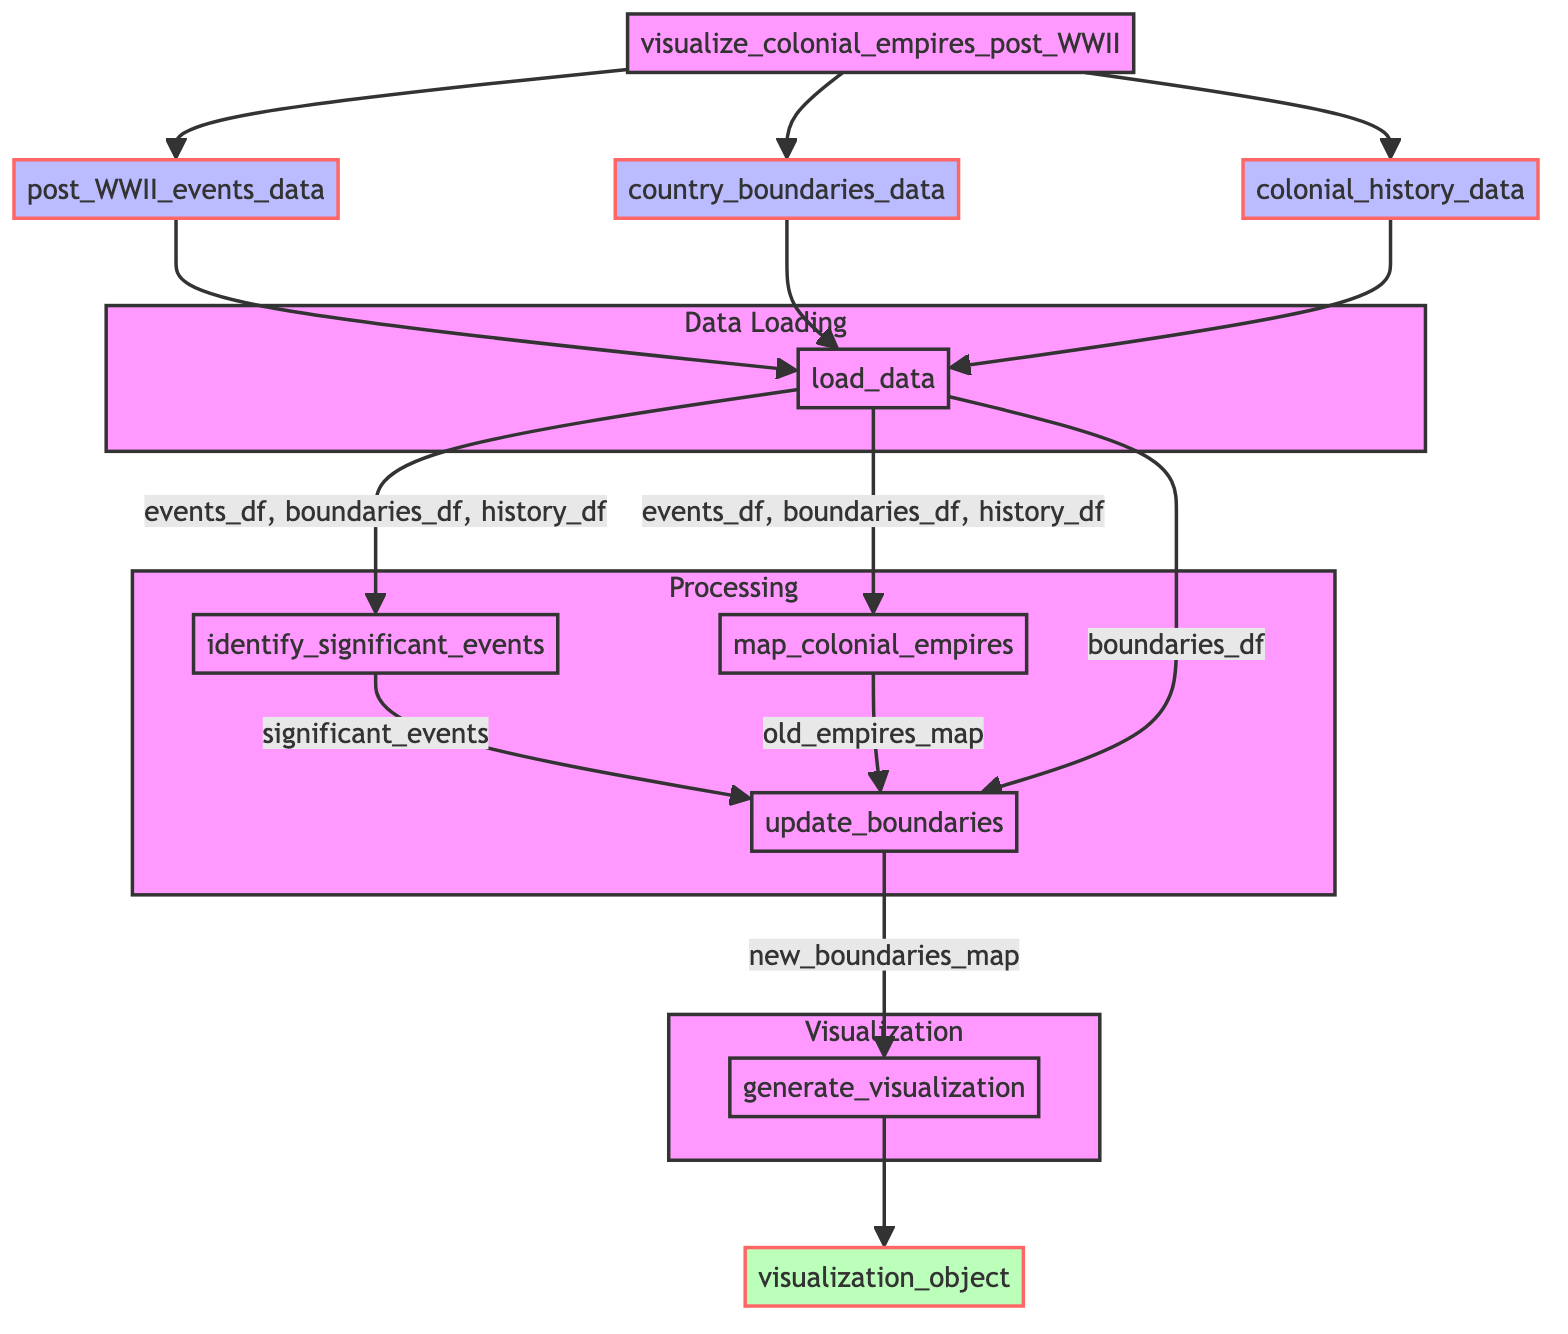What is the first step in the diagram? The first step in the diagram is labeled "load_data." This node represents the initial action taken after receiving the input datasets.
Answer: load_data How many input nodes are there? In the diagram, there are three input nodes: "post_WWII_events_data," "country_boundaries_data," and "colonial_history_data." These nodes provide the necessary data for the function to operate.
Answer: 3 What does "update_boundaries" take as output? The "update_boundaries" step outputs the "new_boundaries_map." This indicates the result of updating the country boundaries based on significant events and old empires.
Answer: new_boundaries_map Which function generates the visualization object? The function that generates the visualization object is "generate_visualization." This node is responsible for creating the final visualization based on the updated boundaries.
Answer: generate_visualization What is the relationship between "identify_significant_events" and "update_boundaries"? The "update_boundaries" function receives its input from "identify_significant_events," specifically the output labeled "significant_events." This indicates a direct flow where significant events influence boundary updates.
Answer: significant_events How many total functions are defined in the processing steps? In the processing steps, there are three functions: "identify_significant_events," "map_colonial_empires," and "update_boundaries." These processes handle the main logic for visualizing the colonial empires.
Answer: 3 What is the final output of the flowchart? The final output of the flowchart is the "visualization_object," which is the end result of the process and represents the visual output of the function.
Answer: visualization_object Which step occurs after "map_colonial_empires"? The step that occurs after "map_colonial_empires" is "update_boundaries." This shows the continuation of steps in processing the data to modify the boundaries based on past empires.
Answer: update_boundaries What data does "load_data" output? The "load_data" function outputs three dataframes: "events_df," "boundaries_df," and "history_df." These are the key inputs for the subsequent steps in the flowchart.
Answer: events_df, boundaries_df, history_df 